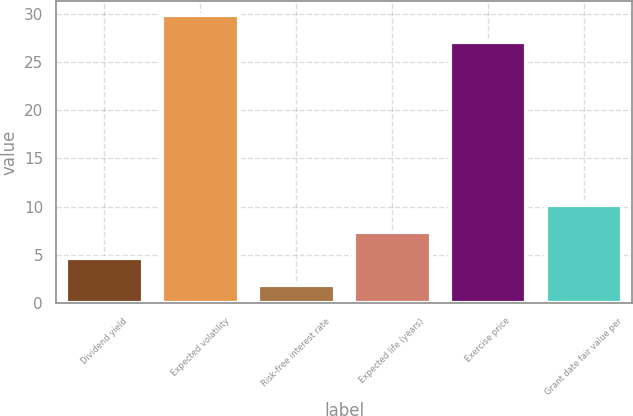Convert chart. <chart><loc_0><loc_0><loc_500><loc_500><bar_chart><fcel>Dividend yield<fcel>Expected volatility<fcel>Risk-free interest rate<fcel>Expected life (years)<fcel>Exercise price<fcel>Grant date fair value per<nl><fcel>4.67<fcel>29.82<fcel>1.93<fcel>7.41<fcel>27.08<fcel>10.15<nl></chart> 